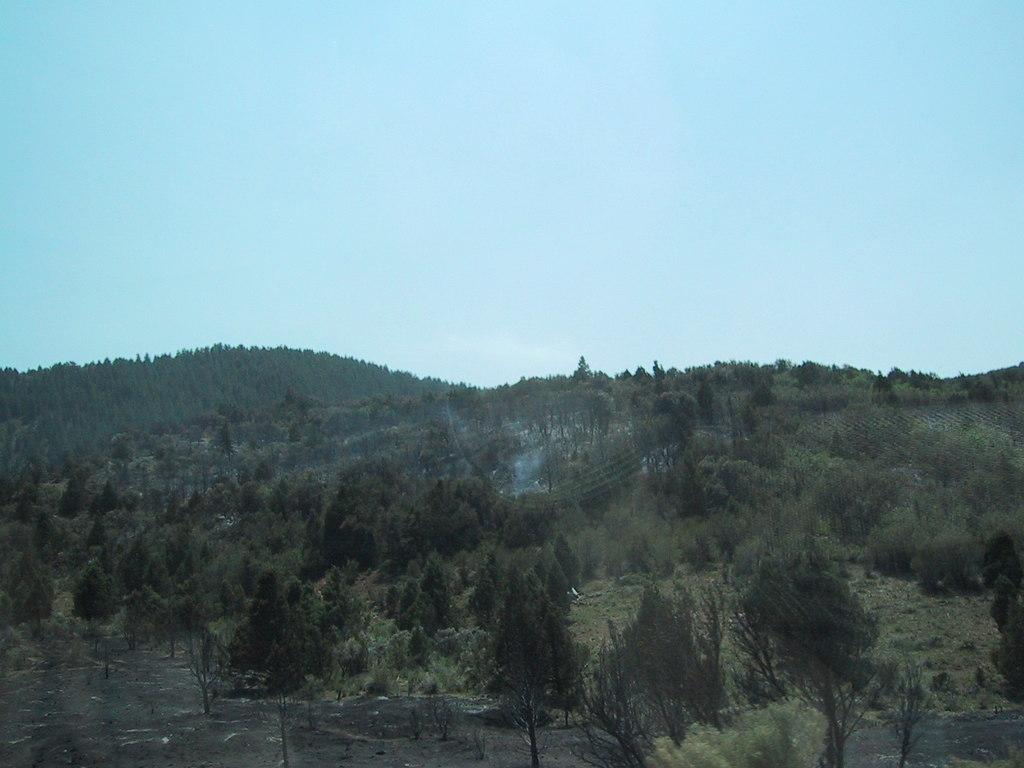What type of vegetation can be seen in the image? There are trees, grass, and plants in the image. What part of the natural environment is visible in the image? The grass and trees are part of the natural environment visible in the image. What is visible in the background of the image? The sky is visible in the background of the image. What type of lumber is being used to construct the building in the image? There is no building present in the image, so it is not possible to determine what type of lumber might be used in its construction. 